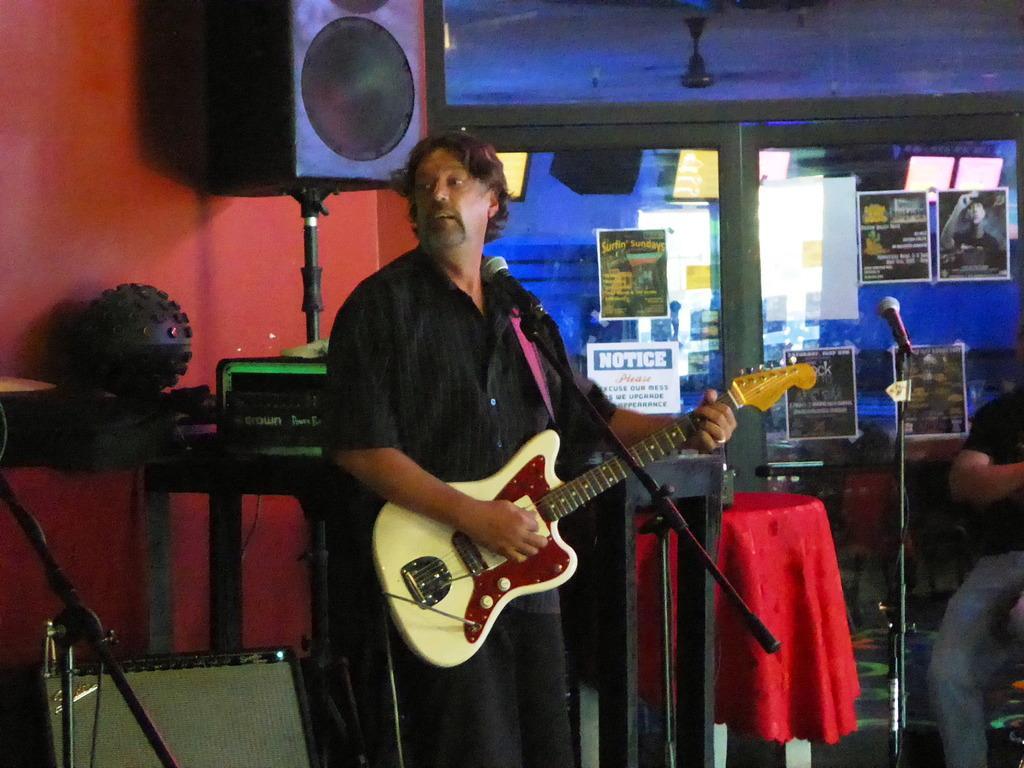In one or two sentences, can you explain what this image depicts? A man is playing guitar. In front of him there is mic. In the right one person is sitting. There are few tables and chair in the picture. There is a speaker behind the man. On the top there is a fan. In the background there is a glass wall on it some palm plate are stick. 